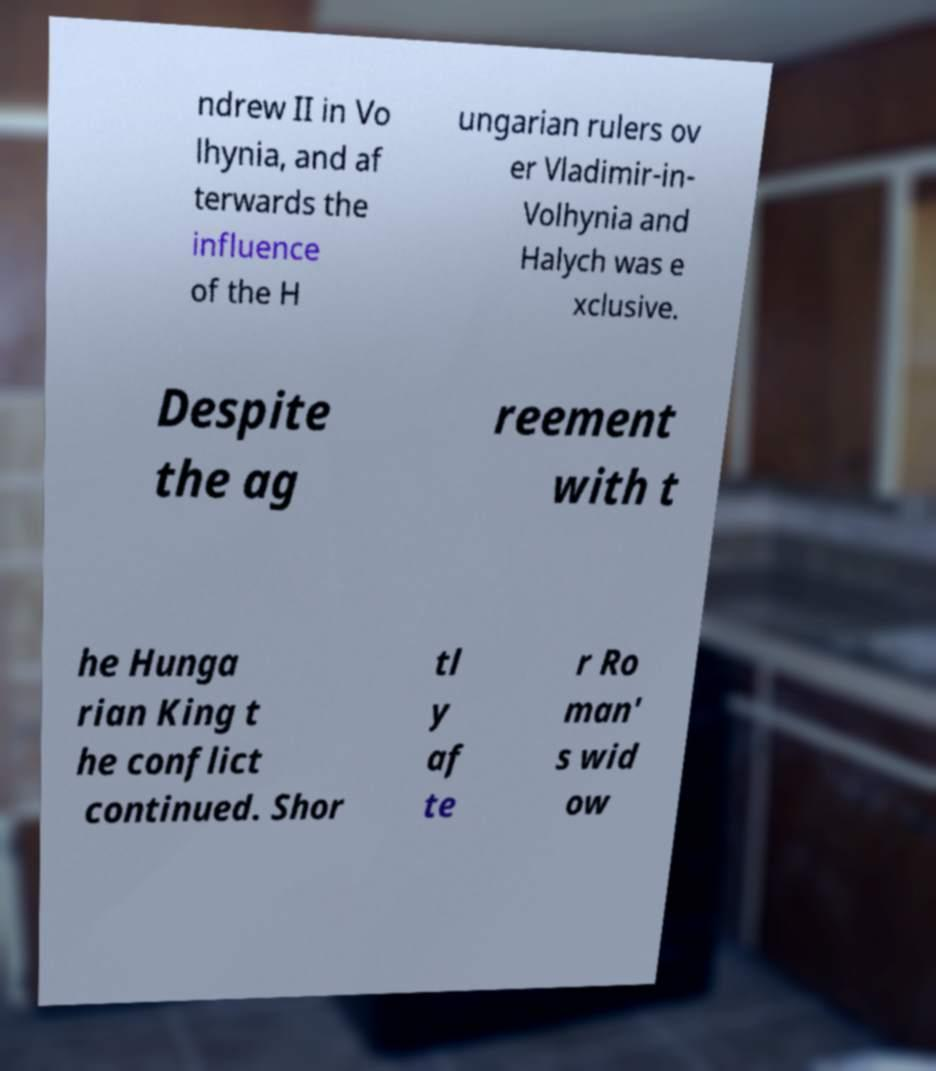Could you assist in decoding the text presented in this image and type it out clearly? ndrew II in Vo lhynia, and af terwards the influence of the H ungarian rulers ov er Vladimir-in- Volhynia and Halych was e xclusive. Despite the ag reement with t he Hunga rian King t he conflict continued. Shor tl y af te r Ro man' s wid ow 